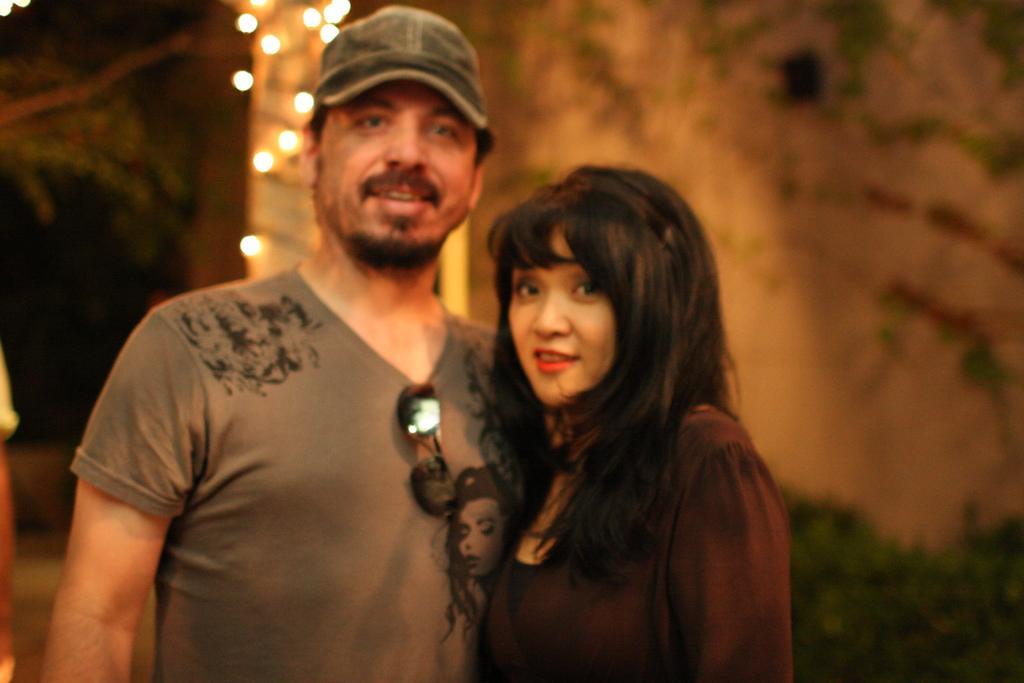Can you describe this image briefly? In this image we can see a man and a woman. The man is wearing a cap and T-shirt. The woman is wearing a brown color dress. In the background, we can see a wall and greenery. There is one more person on the left side of the image. 